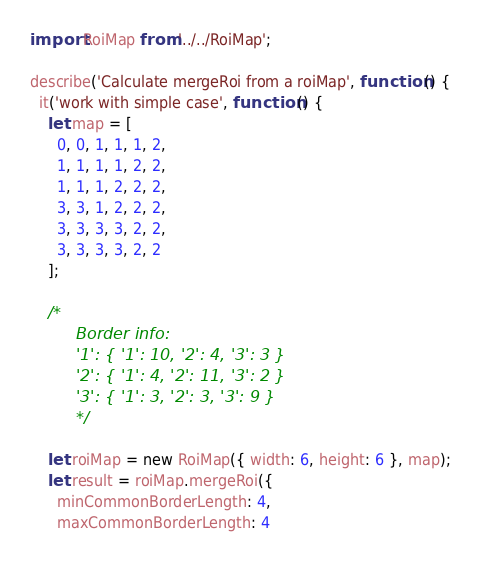Convert code to text. <code><loc_0><loc_0><loc_500><loc_500><_JavaScript_>
import RoiMap from '../../RoiMap';

describe('Calculate mergeRoi from a roiMap', function () {
  it('work with simple case', function () {
    let map = [
      0, 0, 1, 1, 1, 2,
      1, 1, 1, 1, 2, 2,
      1, 1, 1, 2, 2, 2,
      3, 3, 1, 2, 2, 2,
      3, 3, 3, 3, 2, 2,
      3, 3, 3, 3, 2, 2
    ];

    /*
         Border info:
         '1': { '1': 10, '2': 4, '3': 3 }
         '2': { '1': 4, '2': 11, '3': 2 }
         '3': { '1': 3, '2': 3, '3': 9 }
         */

    let roiMap = new RoiMap({ width: 6, height: 6 }, map);
    let result = roiMap.mergeRoi({
      minCommonBorderLength: 4,
      maxCommonBorderLength: 4</code> 